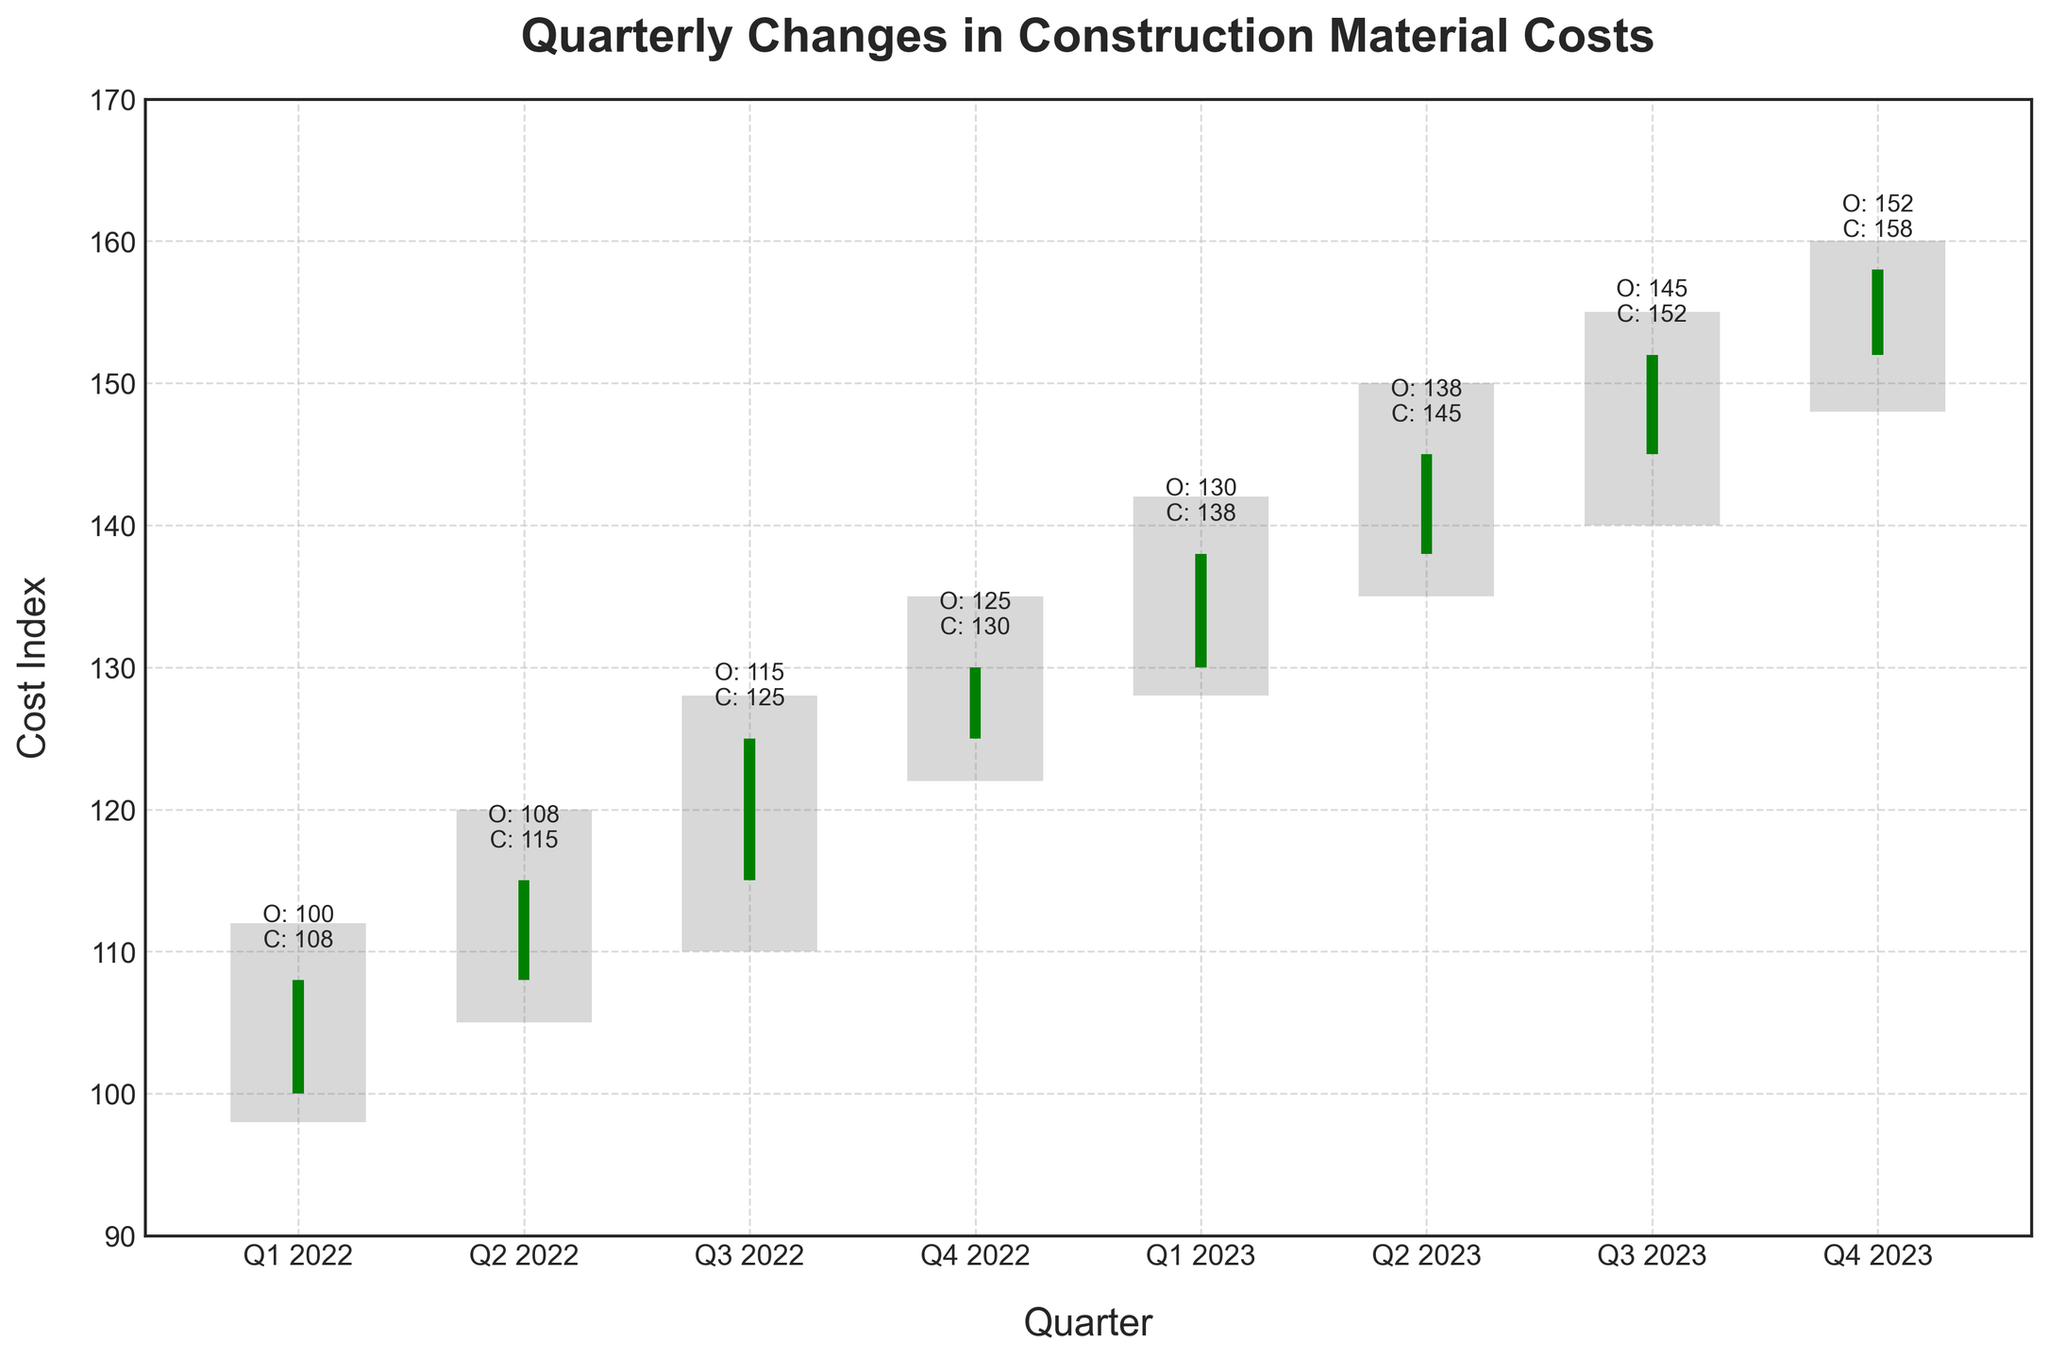What is the title of the chart? The title of the chart is usually displayed at the top of the chart area. In this figure, it is written in bold.
Answer: Quarterly Changes in Construction Material Costs What is the cost index value at the close of Q4 2023? The closing value for Q4 2023 is shown at the top of the bar related to that specific quarter, labeled as 'C: 158'.
Answer: 158 Which quarter had the highest cost index at the high point? By looking for the highest peak in the graph, we can see that Q2 2023 had the highest point, labeled 'High', which is 150.
Answer: Q2 2023 In which quarter did the cost index decrease from its opening to closing values? A decrease is indicated by red bars. Observing the chart, no quarters have red bars, so there were no quarters where the cost index decreased from opening to closing values.
Answer: None Calculate the average closing value for the four quarters in 2022. Adding the closing values for Q1, Q2, Q3, and Q4 2022 gives 108 + 115 + 125 + 130 = 478. Dividing by 4 gives 478 / 4 = 119.5.
Answer: 119.5 What was the cost index range in Q3 2023? The range is calculated by subtracting the low value from the high value in Q3 2023. The values are 155 (high) and 140 (low), so the range is 155 - 140 = 15.
Answer: 15 How many quarters have a closing value above 140? Observing the chart, counting the number of quarters with closing values above 140: Q2 2023, Q3 2023, and Q4 2023, totaling 3 quarters.
Answer: 3 